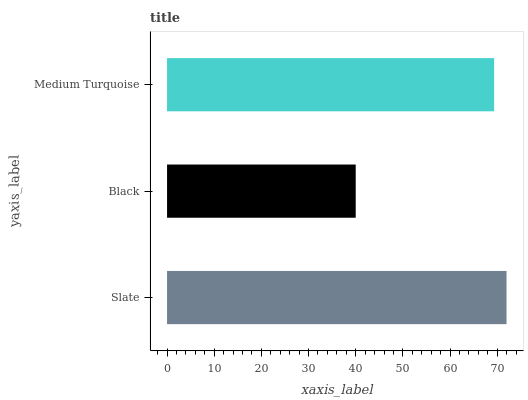Is Black the minimum?
Answer yes or no. Yes. Is Slate the maximum?
Answer yes or no. Yes. Is Medium Turquoise the minimum?
Answer yes or no. No. Is Medium Turquoise the maximum?
Answer yes or no. No. Is Medium Turquoise greater than Black?
Answer yes or no. Yes. Is Black less than Medium Turquoise?
Answer yes or no. Yes. Is Black greater than Medium Turquoise?
Answer yes or no. No. Is Medium Turquoise less than Black?
Answer yes or no. No. Is Medium Turquoise the high median?
Answer yes or no. Yes. Is Medium Turquoise the low median?
Answer yes or no. Yes. Is Slate the high median?
Answer yes or no. No. Is Slate the low median?
Answer yes or no. No. 